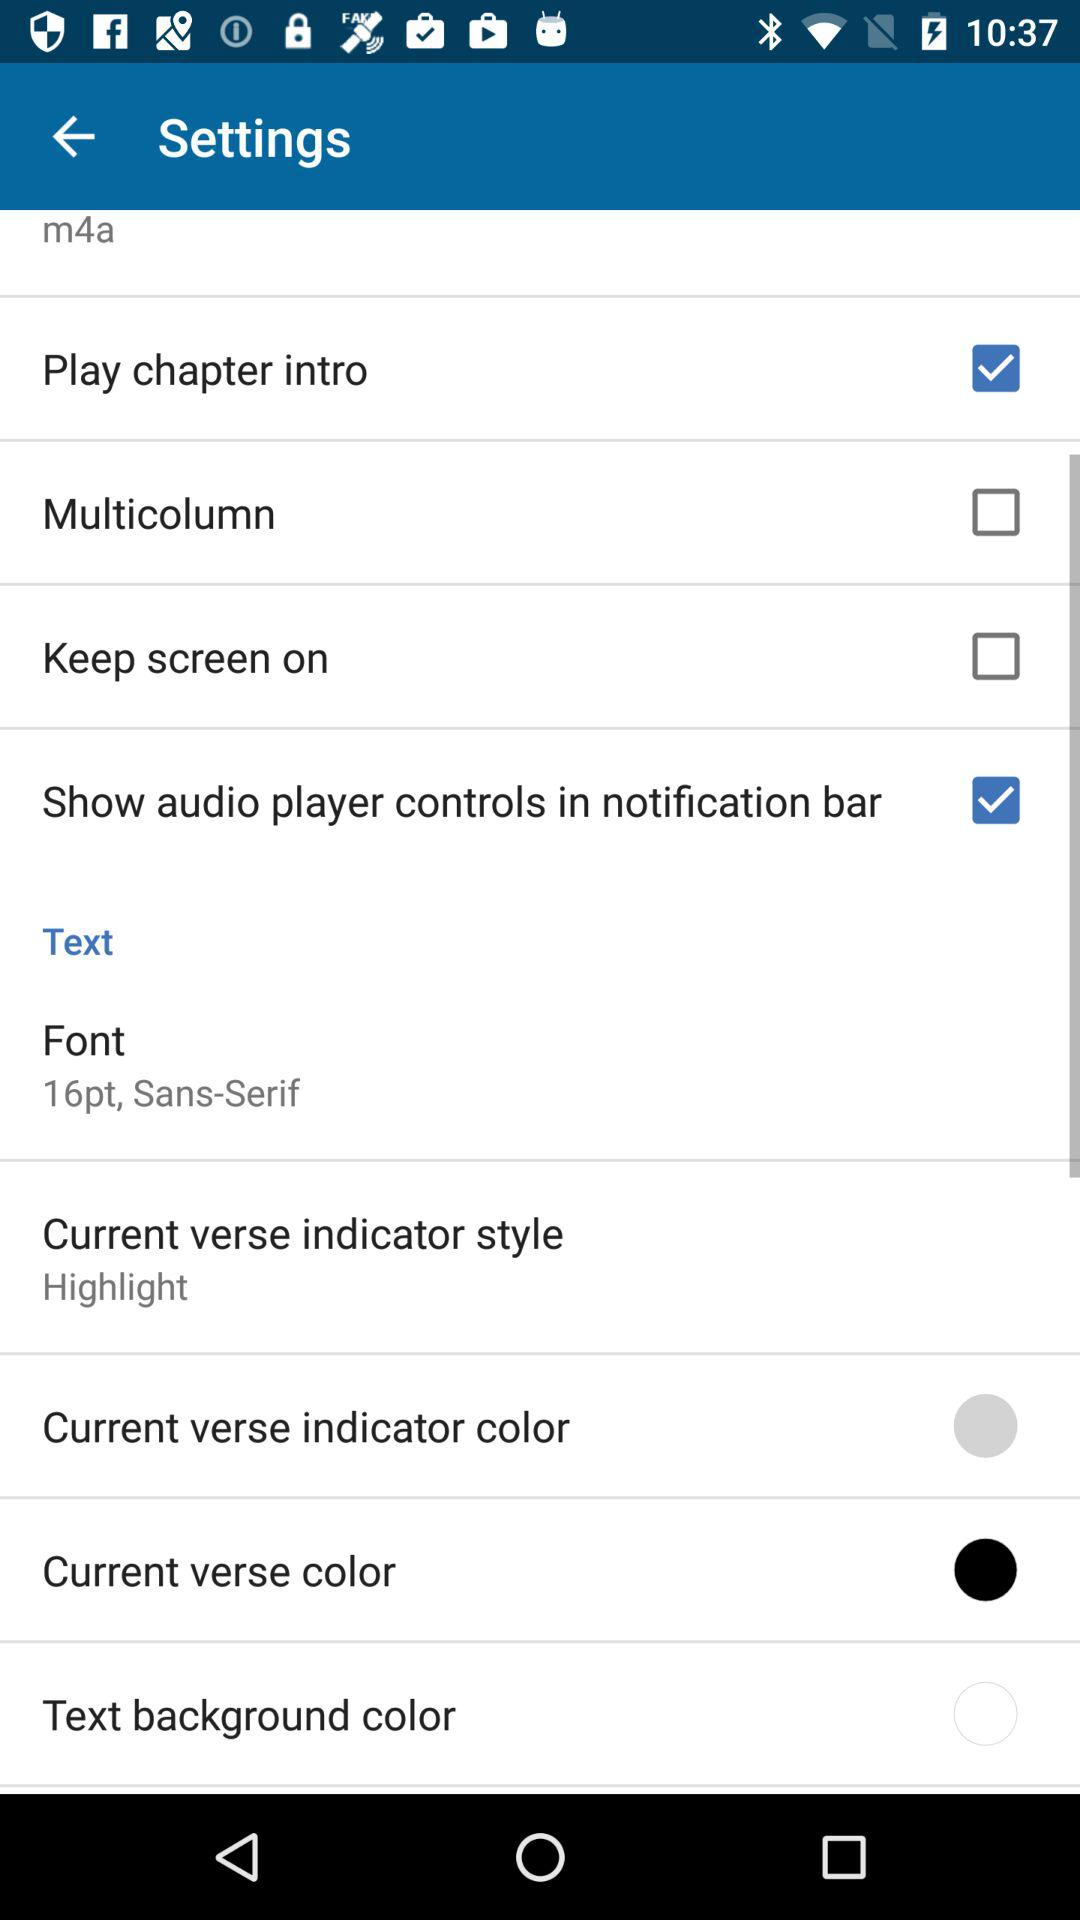What is the Current verse indicator style? The Current verse indicator style is "Highlight". 